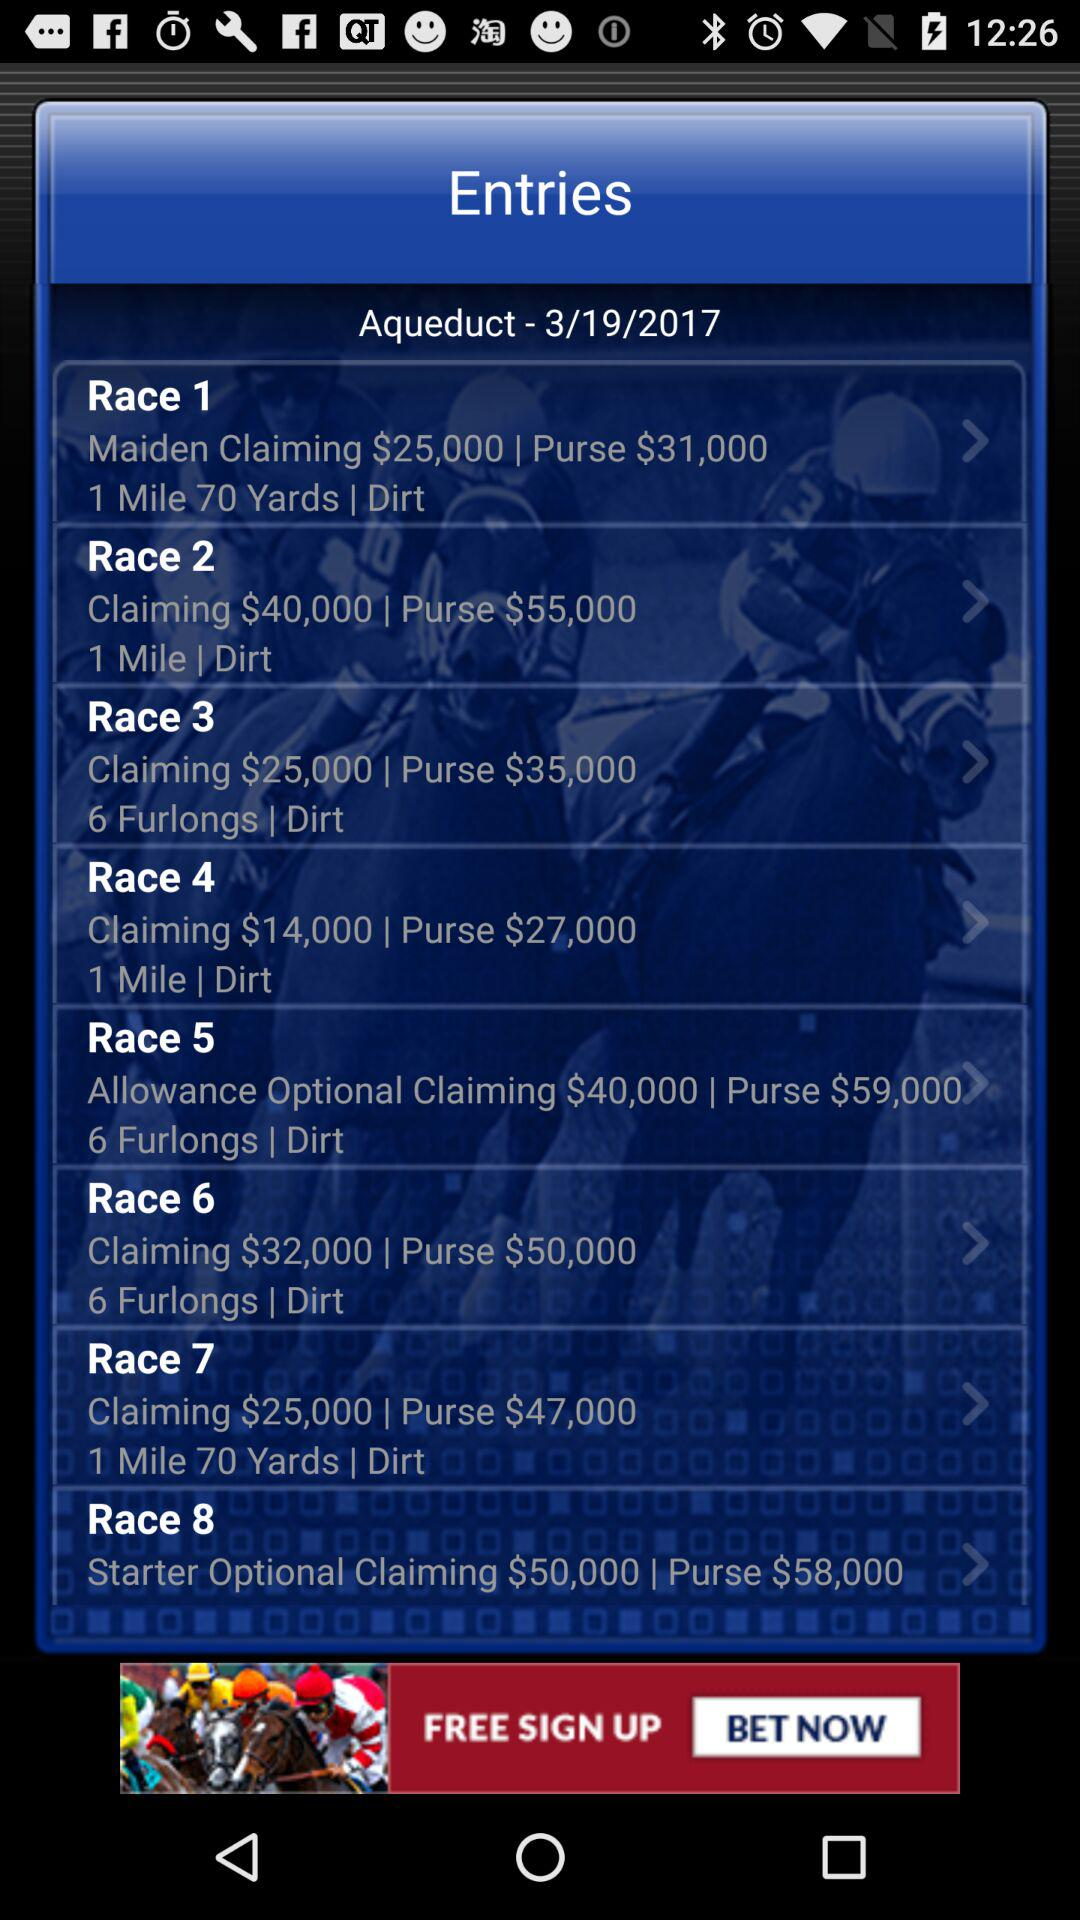How many races are there today?
Answer the question using a single word or phrase. 8 